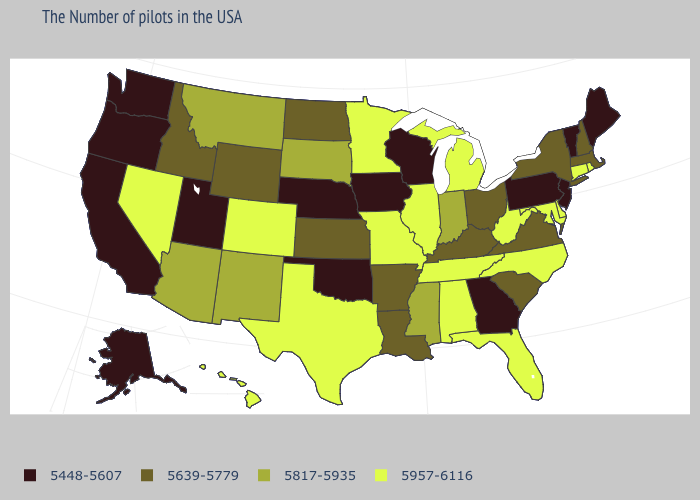Name the states that have a value in the range 5639-5779?
Give a very brief answer. Massachusetts, New Hampshire, New York, Virginia, South Carolina, Ohio, Kentucky, Louisiana, Arkansas, Kansas, North Dakota, Wyoming, Idaho. Does Louisiana have a higher value than Vermont?
Keep it brief. Yes. Is the legend a continuous bar?
Be succinct. No. What is the value of Wyoming?
Keep it brief. 5639-5779. Name the states that have a value in the range 5448-5607?
Give a very brief answer. Maine, Vermont, New Jersey, Pennsylvania, Georgia, Wisconsin, Iowa, Nebraska, Oklahoma, Utah, California, Washington, Oregon, Alaska. What is the value of New Jersey?
Answer briefly. 5448-5607. Name the states that have a value in the range 5639-5779?
Write a very short answer. Massachusetts, New Hampshire, New York, Virginia, South Carolina, Ohio, Kentucky, Louisiana, Arkansas, Kansas, North Dakota, Wyoming, Idaho. Which states have the lowest value in the MidWest?
Concise answer only. Wisconsin, Iowa, Nebraska. Among the states that border New Jersey , does New York have the highest value?
Answer briefly. No. How many symbols are there in the legend?
Keep it brief. 4. Among the states that border Montana , does Wyoming have the highest value?
Concise answer only. No. Among the states that border Kentucky , does Missouri have the highest value?
Short answer required. Yes. Is the legend a continuous bar?
Quick response, please. No. What is the value of Idaho?
Concise answer only. 5639-5779. Does the map have missing data?
Answer briefly. No. 